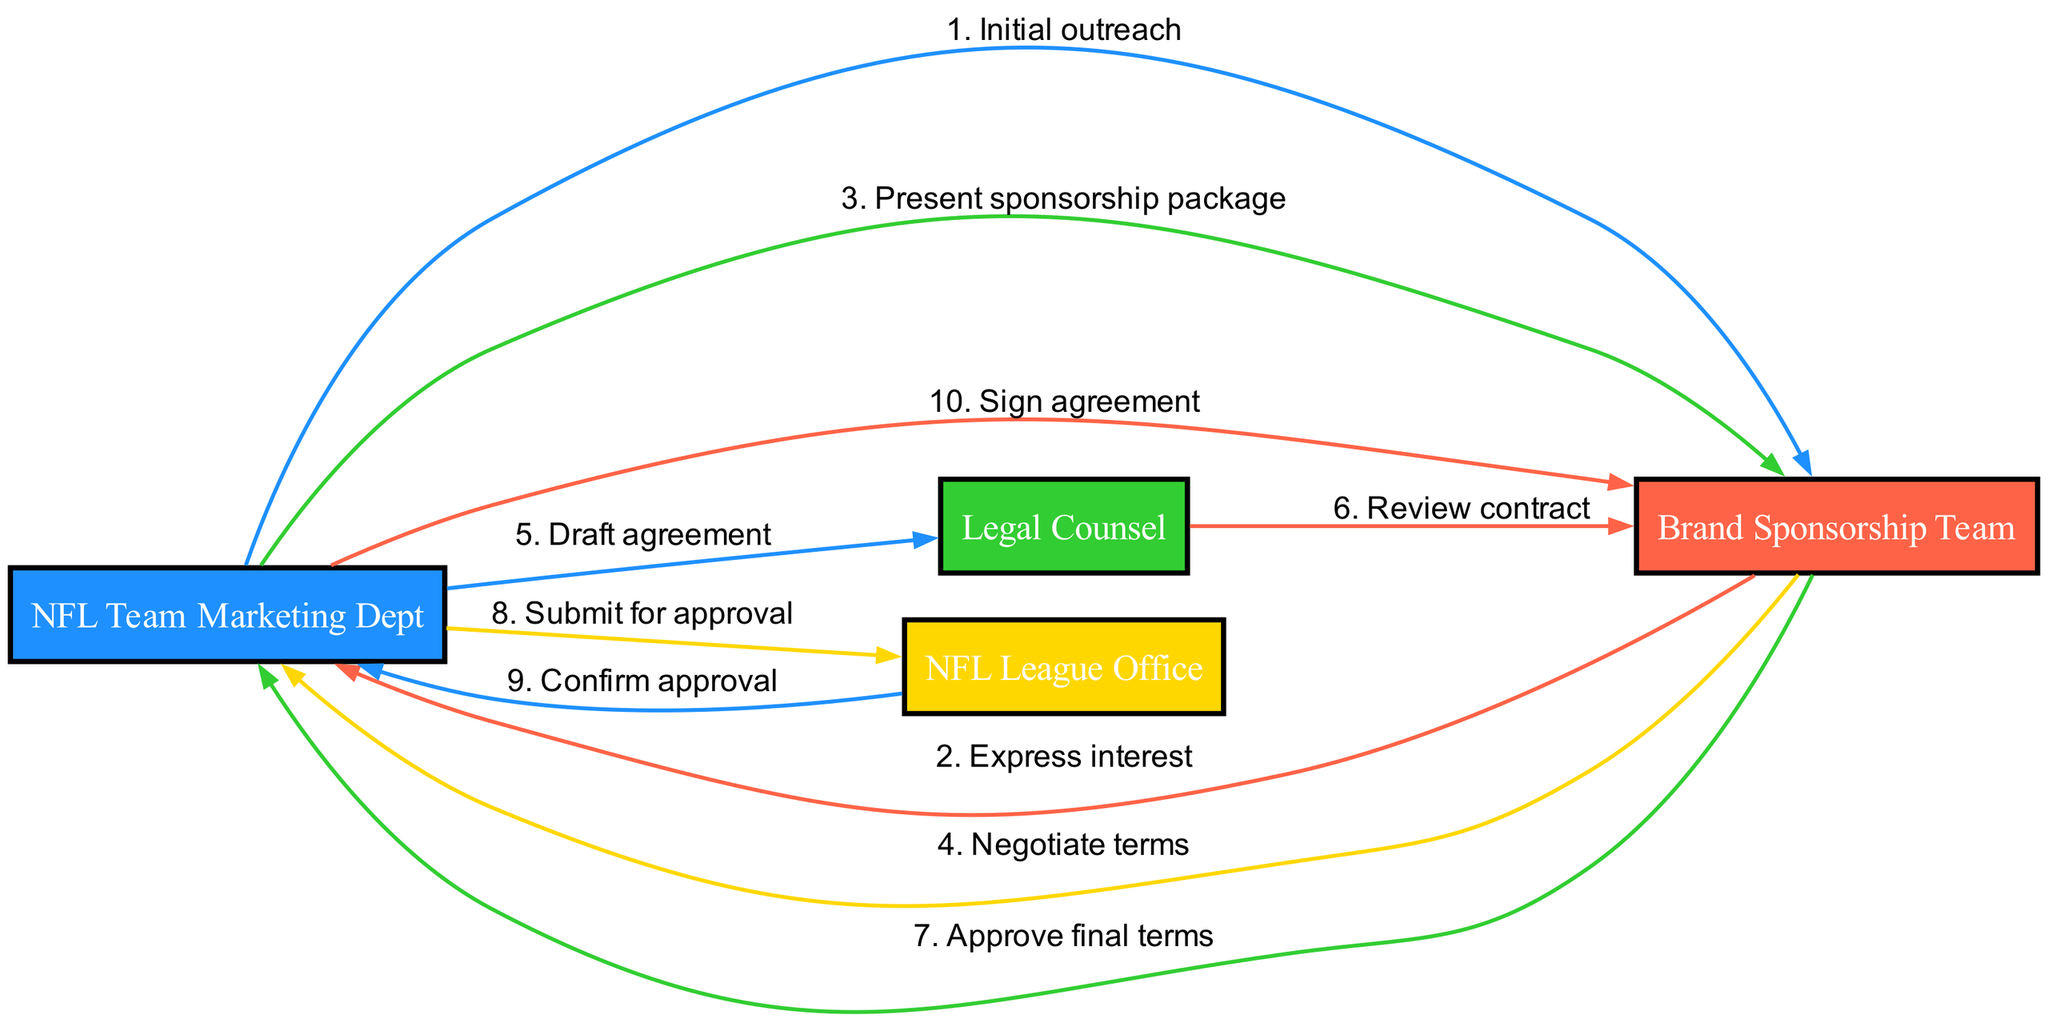What are the actors involved in the negotiation process? The diagram lists four actors: NFL Team Marketing Dept, Brand Sponsorship Team, Legal Counsel, and NFL League Office, which can be observed from the nodes created for each actor.
Answer: NFL Team Marketing Dept, Brand Sponsorship Team, Legal Counsel, NFL League Office How many messages are exchanged in the diagram? By counting the sequence of messages presented in the diagram, we can see there are ten messages listed between different actors, as each step in the sequence represents a message.
Answer: 10 Who initiates the negotiation process? The first message in the sequence is sent from the NFL Team Marketing Dept to the Brand Sponsorship Team, signifying that the NFL Team Marketing Dept initiates the negotiation process.
Answer: NFL Team Marketing Dept What is the last step in the negotiation process? The last step in the sequence diagram involves the NFL Team Marketing Dept signing the agreement, which is the final action that concludes the process.
Answer: Sign agreement Which actor reviews the contract? The message indicates that the Legal Counsel reviews the contract after it has been drafted by the NFL Team Marketing Dept, shown in the sequence step where Legal Counsel communicates with the Brand Sponsorship Team.
Answer: Legal Counsel What message is sent after the terms are negotiated? After the Brand Sponsorship Team negotiates terms with the NFL Team Marketing Dept, the subsequent message exchanged leads to the Legal Counsel drafting the agreement as the next necessary step in the process.
Answer: Draft agreement What is the purpose of the message sent to the NFL League Office? The message to the NFL League Office serves to submit the agreement for approval, indicating that this step is crucial for formalizing the sponsorship deal in compliance with league regulations.
Answer: Submit for approval How does the NFL League Office respond to the submission? The NFL League Office confirms approval as a response to the submission, completing the review process needed for the agreement to be finalized properly.
Answer: Confirm approval Which actor is involved in the contract review? Legal Counsel is involved in the contract review, as depicted in the sequence where they interact with the Brand Sponsorship Team to ensure that all terms are legally sound prior to final approval.
Answer: Legal Counsel What color represents the Brand Sponsorship Team in the diagram? The color assigned to represent the Brand Sponsorship Team in the diagram is red, which is consistently used in the node illustrating their involvement.
Answer: Red 